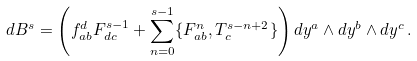<formula> <loc_0><loc_0><loc_500><loc_500>d B ^ { s } = \left ( f _ { a b } ^ { d } F _ { d c } ^ { s - 1 } + \sum _ { n = 0 } ^ { s - 1 } \{ F _ { a b } ^ { n } , T ^ { s - n + 2 } _ { c } \} \right ) d y ^ { a } \wedge d y ^ { b } \wedge d y ^ { c } \, .</formula> 